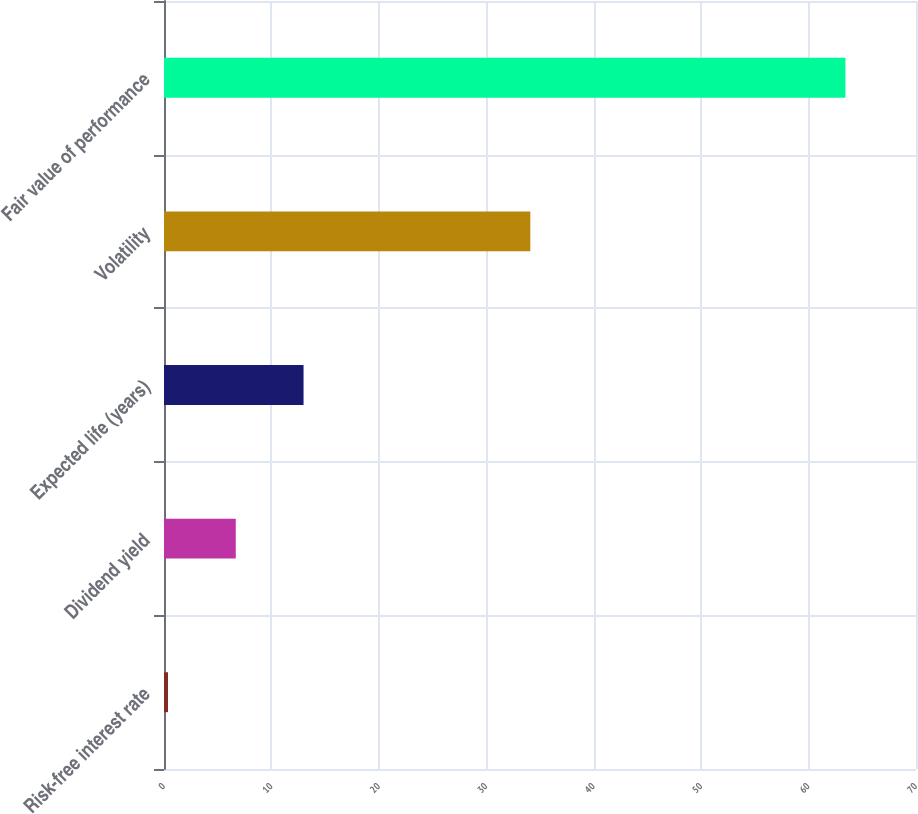Convert chart. <chart><loc_0><loc_0><loc_500><loc_500><bar_chart><fcel>Risk-free interest rate<fcel>Dividend yield<fcel>Expected life (years)<fcel>Volatility<fcel>Fair value of performance<nl><fcel>0.37<fcel>6.68<fcel>12.99<fcel>34.1<fcel>63.43<nl></chart> 